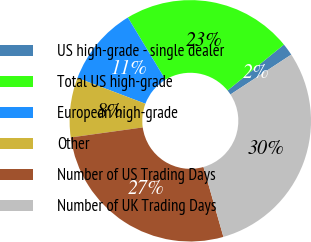Convert chart. <chart><loc_0><loc_0><loc_500><loc_500><pie_chart><fcel>US high-grade - single dealer<fcel>Total US high-grade<fcel>European high-grade<fcel>Other<fcel>Number of US Trading Days<fcel>Number of UK Trading Days<nl><fcel>1.64%<fcel>22.78%<fcel>10.57%<fcel>7.98%<fcel>27.22%<fcel>29.81%<nl></chart> 